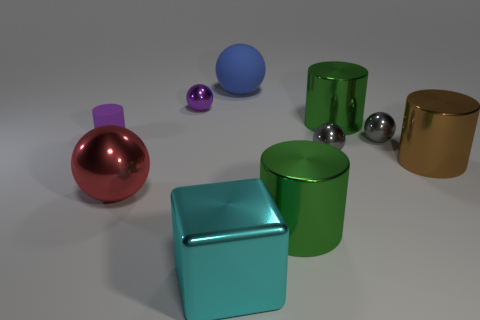Subtract all red spheres. How many spheres are left? 4 Subtract all blue matte spheres. How many spheres are left? 4 Subtract all brown spheres. Subtract all yellow cylinders. How many spheres are left? 5 Subtract all cubes. How many objects are left? 9 Add 1 cyan shiny things. How many cyan shiny things exist? 2 Subtract 0 cyan cylinders. How many objects are left? 10 Subtract all purple matte balls. Subtract all small purple spheres. How many objects are left? 9 Add 9 tiny rubber cylinders. How many tiny rubber cylinders are left? 10 